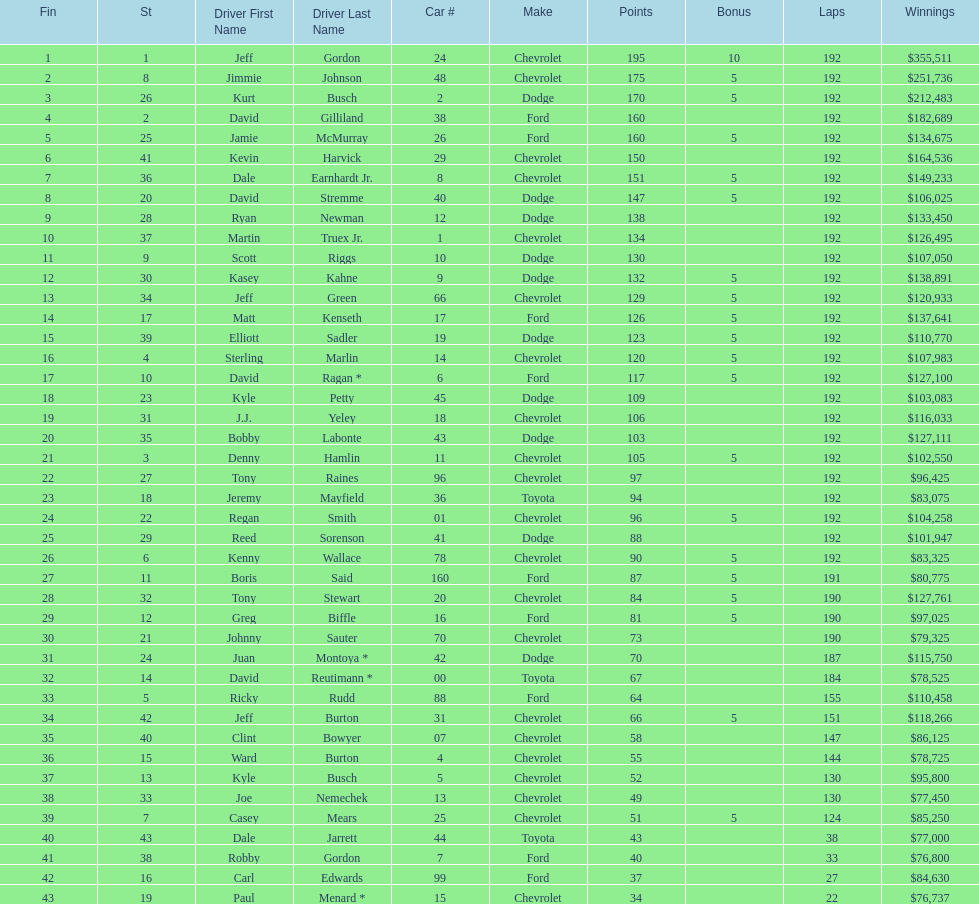I'm looking to parse the entire table for insights. Could you assist me with that? {'header': ['Fin', 'St', 'Driver First Name', 'Driver Last Name', 'Car #', 'Make', 'Points', 'Bonus', 'Laps', 'Winnings'], 'rows': [['1', '1', 'Jeff', 'Gordon', '24', 'Chevrolet', '195', '10', '192', '$355,511'], ['2', '8', 'Jimmie', 'Johnson', '48', 'Chevrolet', '175', '5', '192', '$251,736'], ['3', '26', 'Kurt', 'Busch', '2', 'Dodge', '170', '5', '192', '$212,483'], ['4', '2', 'David', 'Gilliland', '38', 'Ford', '160', '', '192', '$182,689'], ['5', '25', 'Jamie', 'McMurray', '26', 'Ford', '160', '5', '192', '$134,675'], ['6', '41', 'Kevin', 'Harvick', '29', 'Chevrolet', '150', '', '192', '$164,536'], ['7', '36', 'Dale', 'Earnhardt Jr.', '8', 'Chevrolet', '151', '5', '192', '$149,233'], ['8', '20', 'David', 'Stremme', '40', 'Dodge', '147', '5', '192', '$106,025'], ['9', '28', 'Ryan', 'Newman', '12', 'Dodge', '138', '', '192', '$133,450'], ['10', '37', 'Martin', 'Truex Jr.', '1', 'Chevrolet', '134', '', '192', '$126,495'], ['11', '9', 'Scott', 'Riggs', '10', 'Dodge', '130', '', '192', '$107,050'], ['12', '30', 'Kasey', 'Kahne', '9', 'Dodge', '132', '5', '192', '$138,891'], ['13', '34', 'Jeff', 'Green', '66', 'Chevrolet', '129', '5', '192', '$120,933'], ['14', '17', 'Matt', 'Kenseth', '17', 'Ford', '126', '5', '192', '$137,641'], ['15', '39', 'Elliott', 'Sadler', '19', 'Dodge', '123', '5', '192', '$110,770'], ['16', '4', 'Sterling', 'Marlin', '14', 'Chevrolet', '120', '5', '192', '$107,983'], ['17', '10', 'David', 'Ragan *', '6', 'Ford', '117', '5', '192', '$127,100'], ['18', '23', 'Kyle', 'Petty', '45', 'Dodge', '109', '', '192', '$103,083'], ['19', '31', 'J.J.', 'Yeley', '18', 'Chevrolet', '106', '', '192', '$116,033'], ['20', '35', 'Bobby', 'Labonte', '43', 'Dodge', '103', '', '192', '$127,111'], ['21', '3', 'Denny', 'Hamlin', '11', 'Chevrolet', '105', '5', '192', '$102,550'], ['22', '27', 'Tony', 'Raines', '96', 'Chevrolet', '97', '', '192', '$96,425'], ['23', '18', 'Jeremy', 'Mayfield', '36', 'Toyota', '94', '', '192', '$83,075'], ['24', '22', 'Regan', 'Smith', '01', 'Chevrolet', '96', '5', '192', '$104,258'], ['25', '29', 'Reed', 'Sorenson', '41', 'Dodge', '88', '', '192', '$101,947'], ['26', '6', 'Kenny', 'Wallace', '78', 'Chevrolet', '90', '5', '192', '$83,325'], ['27', '11', 'Boris', 'Said', '160', 'Ford', '87', '5', '191', '$80,775'], ['28', '32', 'Tony', 'Stewart', '20', 'Chevrolet', '84', '5', '190', '$127,761'], ['29', '12', 'Greg', 'Biffle', '16', 'Ford', '81', '5', '190', '$97,025'], ['30', '21', 'Johnny', 'Sauter', '70', 'Chevrolet', '73', '', '190', '$79,325'], ['31', '24', 'Juan', 'Montoya *', '42', 'Dodge', '70', '', '187', '$115,750'], ['32', '14', 'David', 'Reutimann *', '00', 'Toyota', '67', '', '184', '$78,525'], ['33', '5', 'Ricky', 'Rudd', '88', 'Ford', '64', '', '155', '$110,458'], ['34', '42', 'Jeff', 'Burton', '31', 'Chevrolet', '66', '5', '151', '$118,266'], ['35', '40', 'Clint', 'Bowyer', '07', 'Chevrolet', '58', '', '147', '$86,125'], ['36', '15', 'Ward', 'Burton', '4', 'Chevrolet', '55', '', '144', '$78,725'], ['37', '13', 'Kyle', 'Busch', '5', 'Chevrolet', '52', '', '130', '$95,800'], ['38', '33', 'Joe', 'Nemechek', '13', 'Chevrolet', '49', '', '130', '$77,450'], ['39', '7', 'Casey', 'Mears', '25', 'Chevrolet', '51', '5', '124', '$85,250'], ['40', '43', 'Dale', 'Jarrett', '44', 'Toyota', '43', '', '38', '$77,000'], ['41', '38', 'Robby', 'Gordon', '7', 'Ford', '40', '', '33', '$76,800'], ['42', '16', 'Carl', 'Edwards', '99', 'Ford', '37', '', '27', '$84,630'], ['43', '19', 'Paul', 'Menard *', '15', 'Chevrolet', '34', '', '22', '$76,737']]} Who got the most bonus points? Jeff Gordon. 